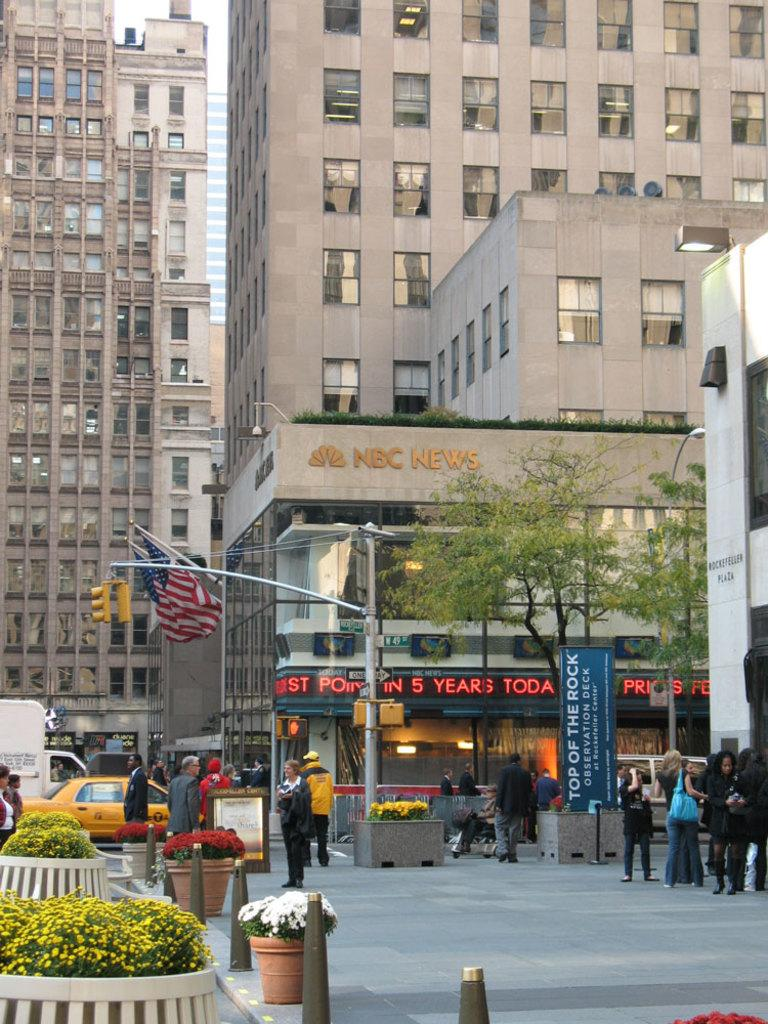<image>
Relay a brief, clear account of the picture shown. A sign that says Top of the rock in front of the NBC News building. 